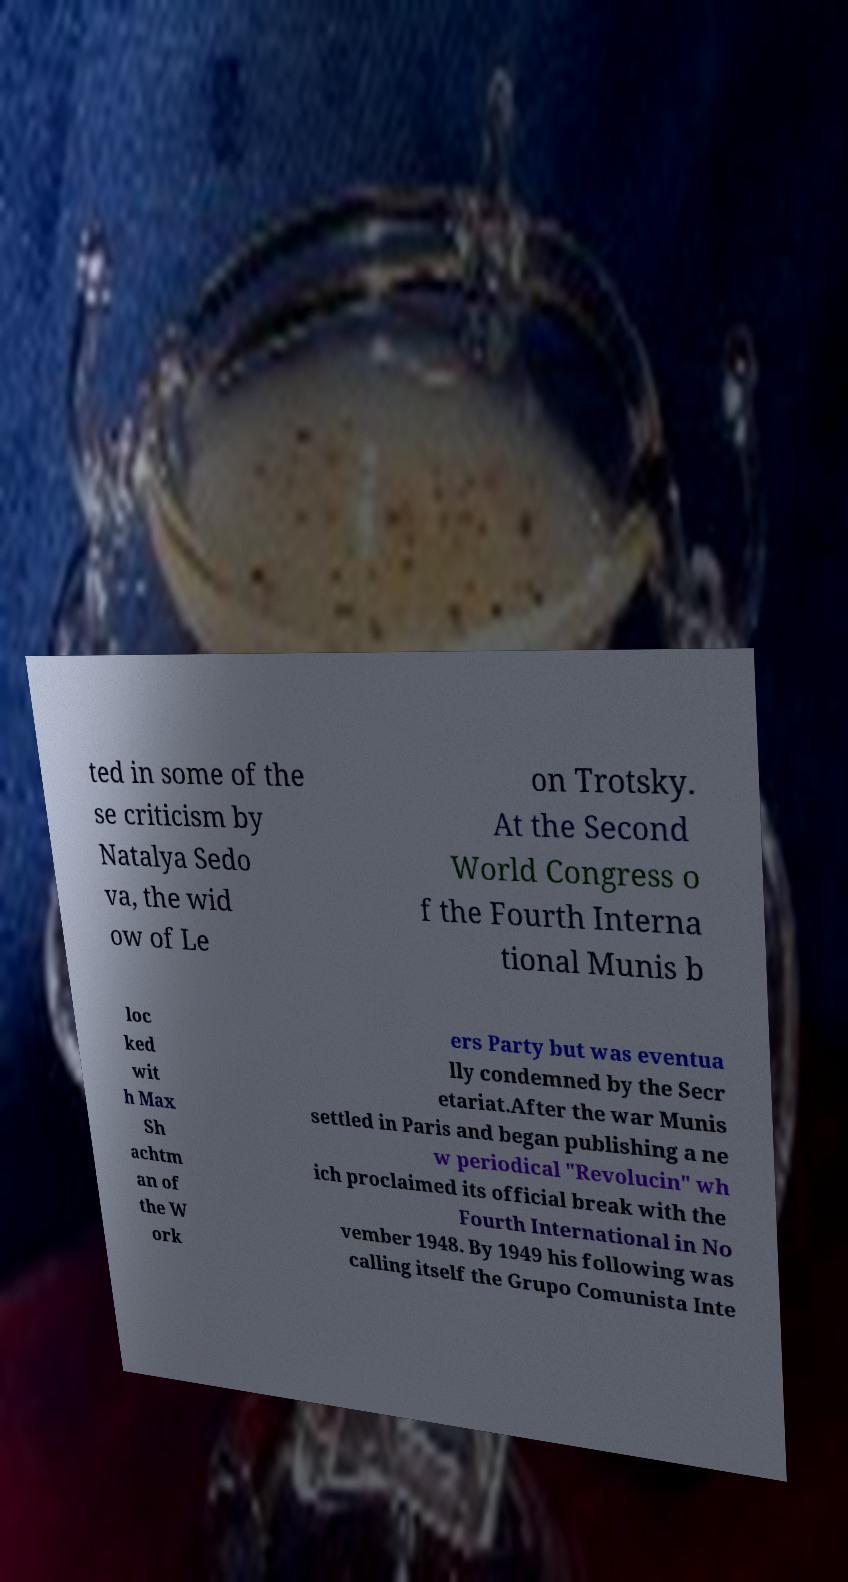There's text embedded in this image that I need extracted. Can you transcribe it verbatim? ted in some of the se criticism by Natalya Sedo va, the wid ow of Le on Trotsky. At the Second World Congress o f the Fourth Interna tional Munis b loc ked wit h Max Sh achtm an of the W ork ers Party but was eventua lly condemned by the Secr etariat.After the war Munis settled in Paris and began publishing a ne w periodical "Revolucin" wh ich proclaimed its official break with the Fourth International in No vember 1948. By 1949 his following was calling itself the Grupo Comunista Inte 